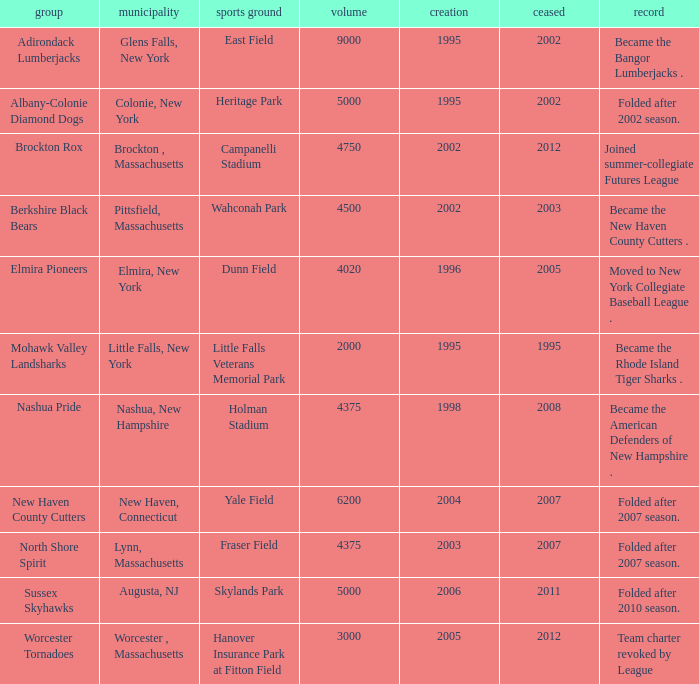Write the full table. {'header': ['group', 'municipality', 'sports ground', 'volume', 'creation', 'ceased', 'record'], 'rows': [['Adirondack Lumberjacks', 'Glens Falls, New York', 'East Field', '9000', '1995', '2002', 'Became the Bangor Lumberjacks .'], ['Albany-Colonie Diamond Dogs', 'Colonie, New York', 'Heritage Park', '5000', '1995', '2002', 'Folded after 2002 season.'], ['Brockton Rox', 'Brockton , Massachusetts', 'Campanelli Stadium', '4750', '2002', '2012', 'Joined summer-collegiate Futures League'], ['Berkshire Black Bears', 'Pittsfield, Massachusetts', 'Wahconah Park', '4500', '2002', '2003', 'Became the New Haven County Cutters .'], ['Elmira Pioneers', 'Elmira, New York', 'Dunn Field', '4020', '1996', '2005', 'Moved to New York Collegiate Baseball League .'], ['Mohawk Valley Landsharks', 'Little Falls, New York', 'Little Falls Veterans Memorial Park', '2000', '1995', '1995', 'Became the Rhode Island Tiger Sharks .'], ['Nashua Pride', 'Nashua, New Hampshire', 'Holman Stadium', '4375', '1998', '2008', 'Became the American Defenders of New Hampshire .'], ['New Haven County Cutters', 'New Haven, Connecticut', 'Yale Field', '6200', '2004', '2007', 'Folded after 2007 season.'], ['North Shore Spirit', 'Lynn, Massachusetts', 'Fraser Field', '4375', '2003', '2007', 'Folded after 2007 season.'], ['Sussex Skyhawks', 'Augusta, NJ', 'Skylands Park', '5000', '2006', '2011', 'Folded after 2010 season.'], ['Worcester Tornadoes', 'Worcester , Massachusetts', 'Hanover Insurance Park at Fitton Field', '3000', '2005', '2012', 'Team charter revoked by League']]} What is the maximum folded value of the team whose stadium is Fraser Field? 2007.0. 